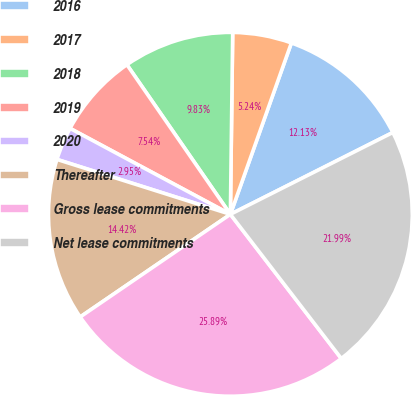Convert chart. <chart><loc_0><loc_0><loc_500><loc_500><pie_chart><fcel>2016<fcel>2017<fcel>2018<fcel>2019<fcel>2020<fcel>Thereafter<fcel>Gross lease commitments<fcel>Net lease commitments<nl><fcel>12.13%<fcel>5.24%<fcel>9.83%<fcel>7.54%<fcel>2.95%<fcel>14.42%<fcel>25.89%<fcel>21.99%<nl></chart> 